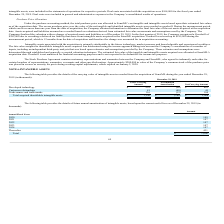From Quicklogic Corporation's financial document, What are the respective gross and net carrying amount of developed technology? The document shows two values: $959 and $863 (in thousands). From the document: "Developed technology $ 959 $ (96) $ 863 Developed technology $ 959 $ (96) $ 863..." Also, What are the respective gross and net carrying amount of customer relationships? The document shows two values: 81 and 41 (in thousands). From the document: "Customer relationships 81 (40) 41 Customer relationships 81 (40) 41..." Also, What are the respective gross and net carrying amount of trade names and trade marks? The document shows two values: 116 and 104 (in thousands). From the document: "Trade names and trade marks 116 (12) 104 Trade names and trade marks 116 (12) 104..." Also, can you calculate: What is the value of the net carrying amount of the developed technology as a percentage of the gross carrying amount? Based on the calculation: 863/959 , the result is 89.99 (percentage). This is based on the information: "Developed technology $ 959 $ (96) $ 863 Developed technology $ 959 $ (96) $ 863..." The key data points involved are: 863, 959. Also, can you calculate: What is the value of the net carrying amount of customer relationships as a percentage of the gross carrying amount? Based on the calculation: 41/81 , the result is 50.62 (percentage). This is based on the information: "Customer relationships 81 (40) 41 Customer relationships 81 (40) 41..." The key data points involved are: 41, 81. Also, can you calculate: What is the value of the net carrying amount of trade names and trade marks as a percentage of the gross carrying amount? Based on the calculation: 104/116 , the result is 89.66 (percentage). This is based on the information: "Trade names and trade marks 116 (12) 104 Trade names and trade marks 116 (12) 104..." The key data points involved are: 104, 116. 